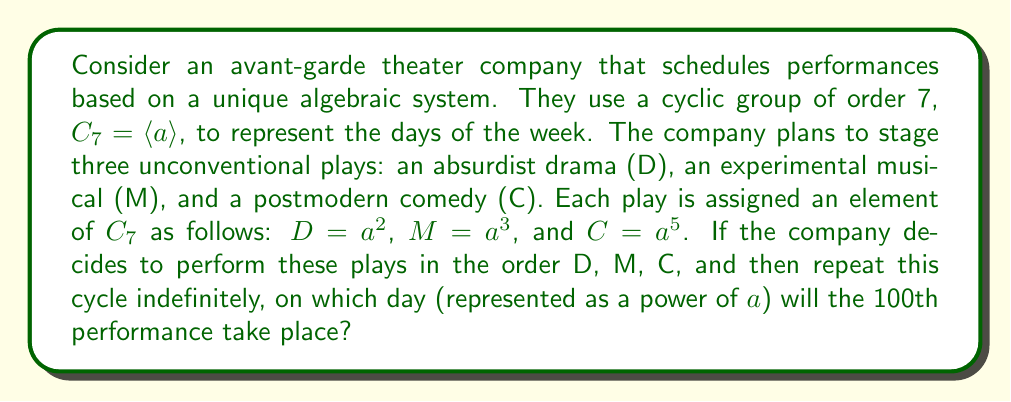Help me with this question. Let's approach this step-by-step:

1) First, we need to understand what each performance represents in the group $C_7$:
   D = $a^2$
   M = $a^3$
   C = $a^5$

2) One cycle of performances (D, M, C) can be represented as:
   $a^2 \cdot a^3 \cdot a^5 = a^{10} = a^3$ (since $a^7 = e$ in $C_7$)

3) This means that after each cycle, we move forward by $a^3$ in the group.

4) To find the 100th performance, we need to:
   a) Determine how many complete cycles have occurred
   b) Calculate the remaining performances in the incomplete cycle

5) Number of complete cycles: $\lfloor 100 / 3 \rfloor = 33$
   Remaining performances: $100 \bmod 3 = 1$

6) 33 complete cycles translate to: $(a^3)^{33} = a^{99} = a^1 = a$ (since $a^7 = e$)

7) The remaining 1 performance is D, which is $a^2$

8) Therefore, the 100th performance occurs on:
   $a \cdot a^2 = a^3$
Answer: $a^3$ 